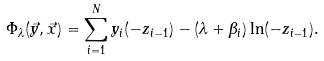Convert formula to latex. <formula><loc_0><loc_0><loc_500><loc_500>\Phi _ { \lambda } ( { \vec { y } } , { \vec { x } } ) = \sum _ { i = 1 } ^ { N } y _ { i } ( - z _ { i - 1 } ) - ( \lambda + \beta _ { i } ) \ln ( - z _ { i - 1 } ) .</formula> 